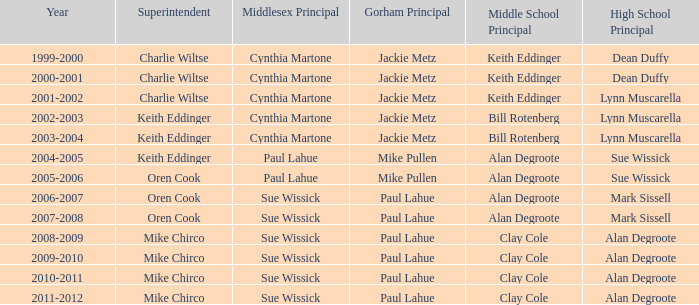Who were the middle school principal(s) in 2010-2011? Clay Cole. 